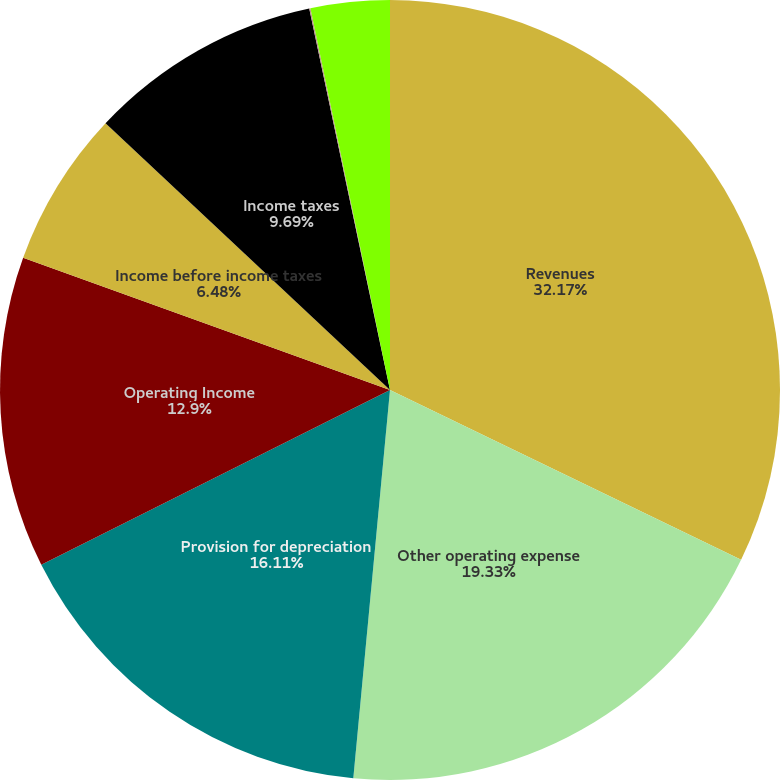Convert chart to OTSL. <chart><loc_0><loc_0><loc_500><loc_500><pie_chart><fcel>Revenues<fcel>Other operating expense<fcel>Provision for depreciation<fcel>Operating Income<fcel>Income before income taxes<fcel>Income taxes<fcel>Net Income<fcel>Earnings available to Parent<nl><fcel>32.17%<fcel>19.33%<fcel>16.11%<fcel>12.9%<fcel>6.48%<fcel>9.69%<fcel>0.05%<fcel>3.27%<nl></chart> 